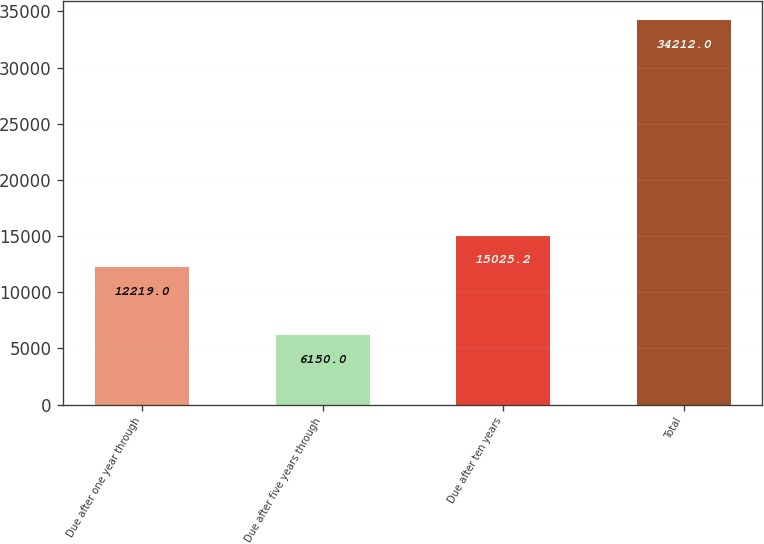Convert chart to OTSL. <chart><loc_0><loc_0><loc_500><loc_500><bar_chart><fcel>Due after one year through<fcel>Due after five years through<fcel>Due after ten years<fcel>Total<nl><fcel>12219<fcel>6150<fcel>15025.2<fcel>34212<nl></chart> 